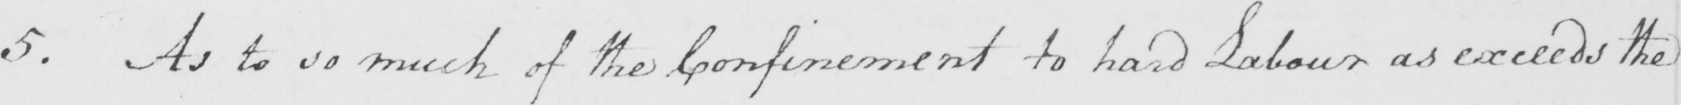What is written in this line of handwriting? 5 . As to so much of the Confinement to hard labour as exceeds the 